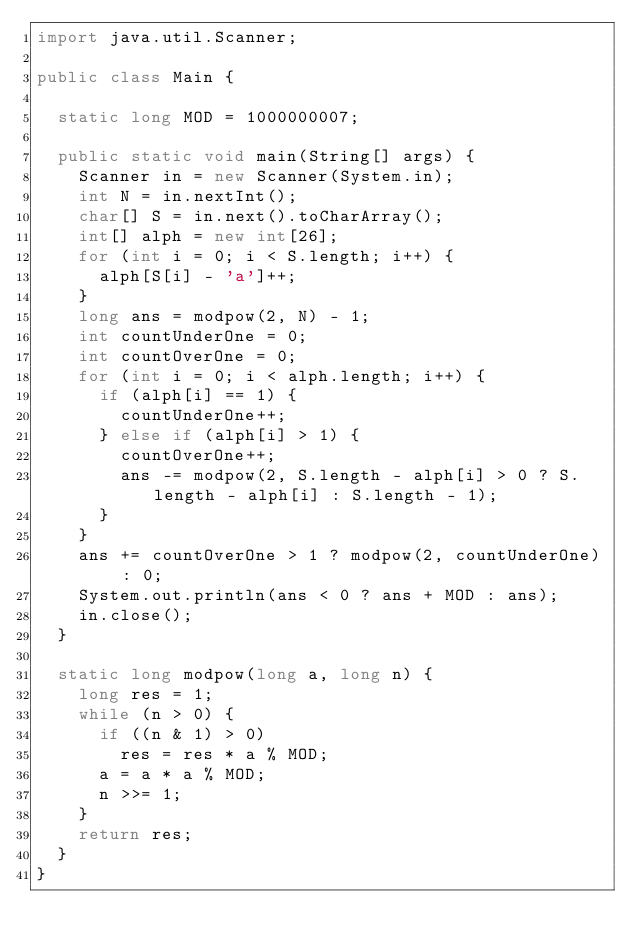Convert code to text. <code><loc_0><loc_0><loc_500><loc_500><_Java_>import java.util.Scanner;

public class Main {

	static long MOD = 1000000007;

	public static void main(String[] args) {
		Scanner in = new Scanner(System.in);
		int N = in.nextInt();
		char[] S = in.next().toCharArray();
		int[] alph = new int[26];
		for (int i = 0; i < S.length; i++) {
			alph[S[i] - 'a']++;
		}
		long ans = modpow(2, N) - 1;
		int countUnderOne = 0;
		int countOverOne = 0;
		for (int i = 0; i < alph.length; i++) {
			if (alph[i] == 1) {
				countUnderOne++;
			} else if (alph[i] > 1) {
				countOverOne++;
				ans -= modpow(2, S.length - alph[i] > 0 ? S.length - alph[i] : S.length - 1);
			}
		}
		ans += countOverOne > 1 ? modpow(2, countUnderOne) : 0;
		System.out.println(ans < 0 ? ans + MOD : ans);
		in.close();
	}

	static long modpow(long a, long n) {
		long res = 1;
		while (n > 0) {
			if ((n & 1) > 0)
				res = res * a % MOD;
			a = a * a % MOD;
			n >>= 1;
		}
		return res;
	}
}</code> 